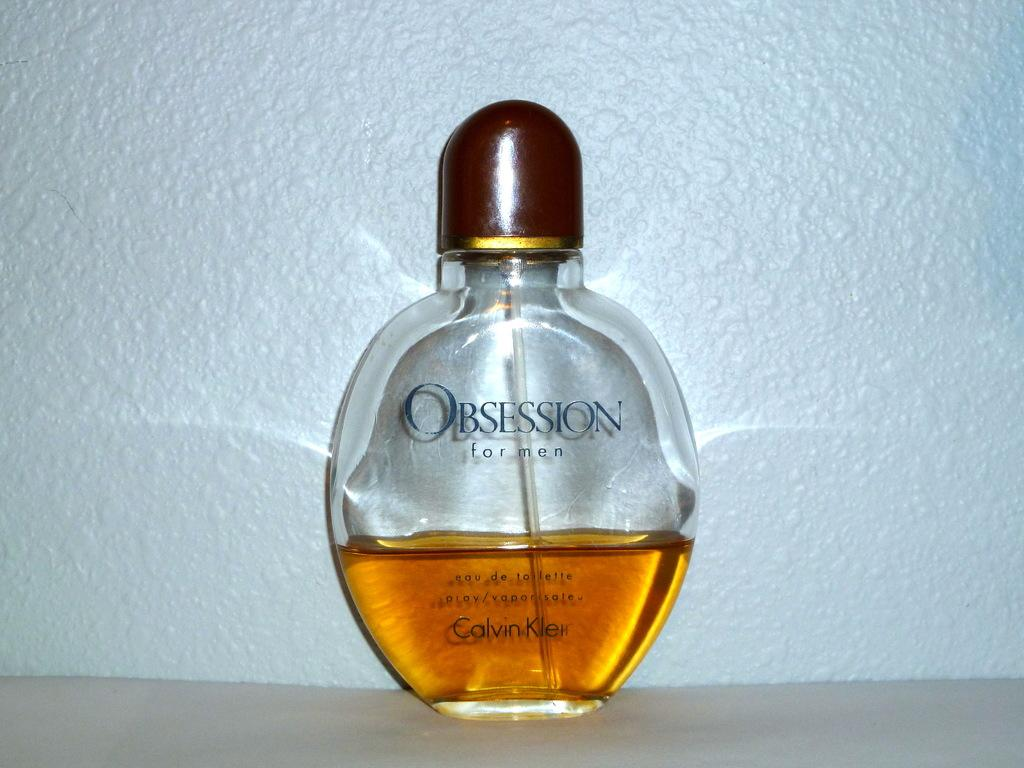<image>
Render a clear and concise summary of the photo. Calvin Klein makes Obsession eau de toilette for men. 